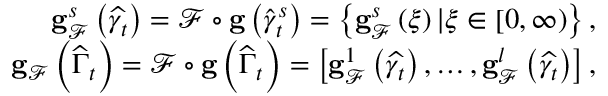<formula> <loc_0><loc_0><loc_500><loc_500>\begin{array} { r } { g _ { \mathcal { F } } ^ { s } \left ( \widehat { \gamma _ { t } } \right ) = \mathcal { F } \circ g \left ( \widehat { \gamma } _ { t } ^ { s } \right ) = \left \{ g _ { \mathcal { F } } ^ { s } \left ( \xi \right ) | \xi \in \left [ 0 , \infty \right ) \right \} , } \\ { g _ { \mathcal { F } } \left ( \widehat { \Gamma } _ { t } \right ) = \mathcal { F } \circ g \left ( \widehat { \Gamma } _ { t } \right ) = \left [ g _ { \mathcal { F } } ^ { 1 } \left ( \widehat { \gamma _ { t } } \right ) , \dots , g _ { \mathcal { F } } ^ { l } \left ( \widehat { \gamma _ { t } } \right ) \right ] , } \end{array}</formula> 